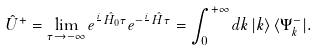Convert formula to latex. <formula><loc_0><loc_0><loc_500><loc_500>\hat { U } ^ { + } = \lim _ { \tau \to - \infty } e ^ { \frac { i } { } \, \hat { H } _ { 0 } \tau } e ^ { - \frac { i } { } \, \hat { H } \tau } = \int _ { 0 } ^ { + \infty } d k \, | k \rangle \, \langle \Psi _ { k } ^ { - } | .</formula> 